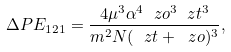Convert formula to latex. <formula><loc_0><loc_0><loc_500><loc_500>\Delta P E _ { 1 2 1 } = \frac { 4 \mu ^ { 3 } \alpha ^ { 4 } \ z o ^ { 3 } \ z t ^ { 3 } } { m ^ { 2 } N ( \ z t + \ z o ) ^ { 3 } } ,</formula> 